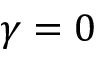Convert formula to latex. <formula><loc_0><loc_0><loc_500><loc_500>\gamma = 0</formula> 